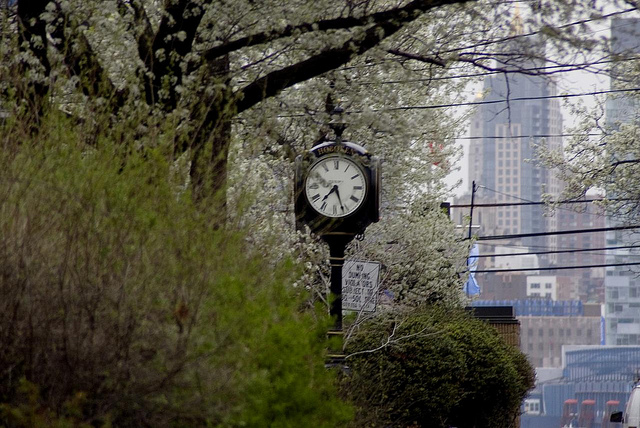<image>What building is the clock on? There is no building in the image where the clock is located. However, it can be on a park, post, roof, or pole. How long must you wait for a bus if you arrive at 6AM? It is unknown how long you must wait for a bus if you arrive at 6AM. It could vary. What building is the clock on? I am not sure what building the clock is on. There is no building visible in the image. How long must you wait for a bus if you arrive at 6AM? I don't know how long you must wait for a bus if you arrive at 6AM. It can be 90 minutes, 3 hours, 2 hours, or any other time. 